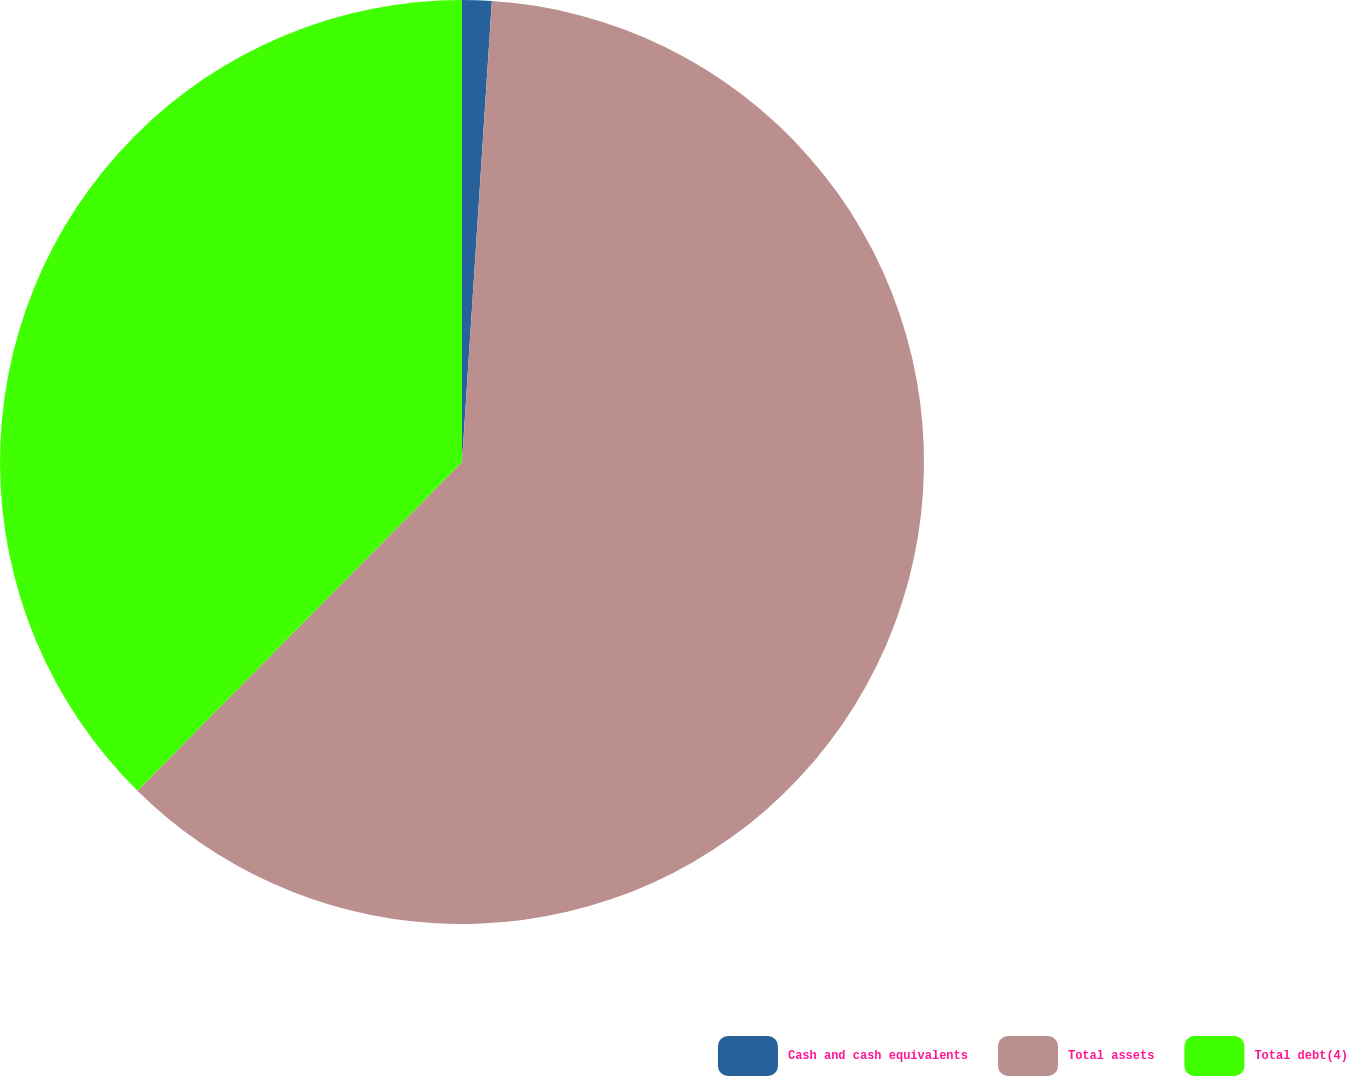Convert chart. <chart><loc_0><loc_0><loc_500><loc_500><pie_chart><fcel>Cash and cash equivalents<fcel>Total assets<fcel>Total debt(4)<nl><fcel>1.03%<fcel>61.37%<fcel>37.6%<nl></chart> 